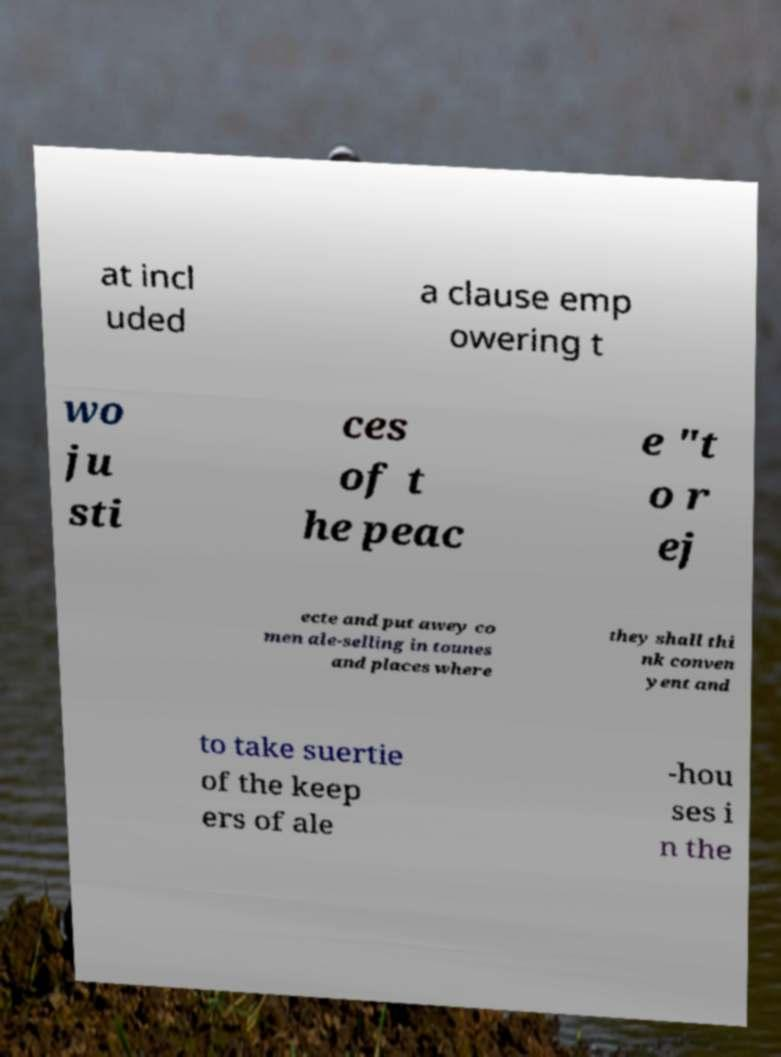Can you accurately transcribe the text from the provided image for me? at incl uded a clause emp owering t wo ju sti ces of t he peac e "t o r ej ecte and put awey co men ale-selling in tounes and places where they shall thi nk conven yent and to take suertie of the keep ers of ale -hou ses i n the 